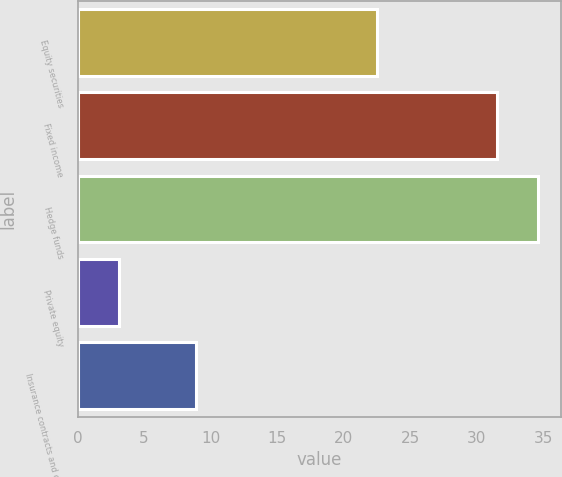Convert chart to OTSL. <chart><loc_0><loc_0><loc_500><loc_500><bar_chart><fcel>Equity securities<fcel>Fixed income<fcel>Hedge funds<fcel>Private equity<fcel>Insurance contracts and other<nl><fcel>22.5<fcel>31.5<fcel>34.59<fcel>3.1<fcel>8.9<nl></chart> 